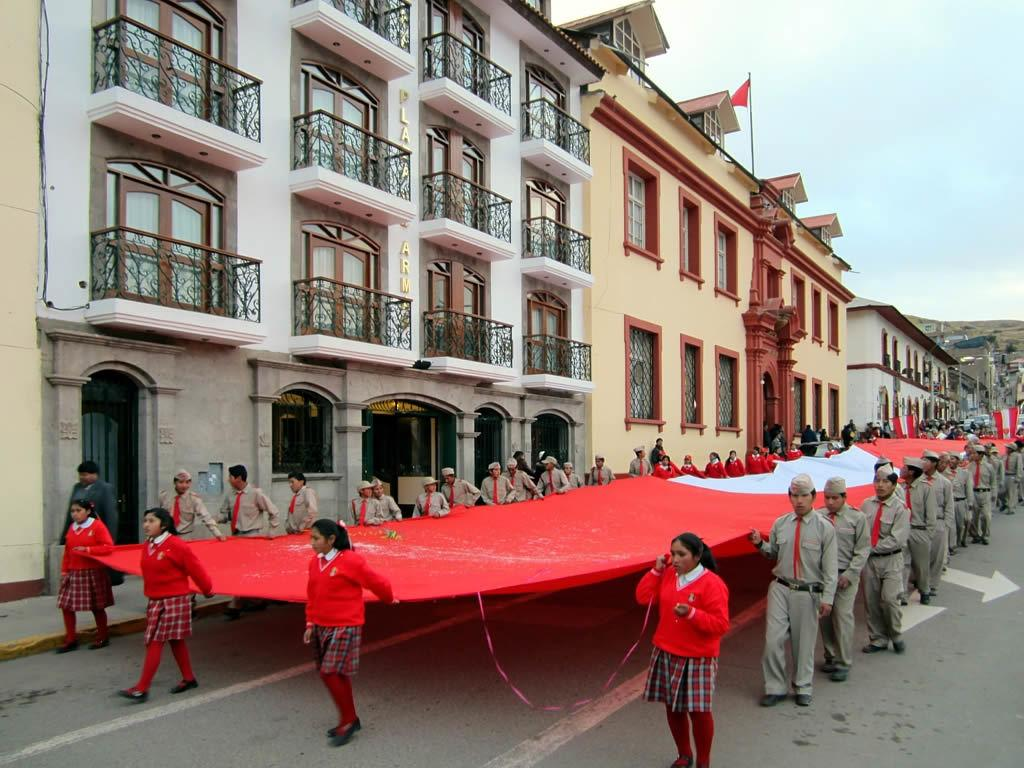What are the people in the image doing? The people in the image are walking on the road. What are the people holding while walking? The people are holding a cloth. What can be seen in the background of the image? There are buildings visible near the side of the road. How many giants can be seen walking on the road in the image? There are no giants present in the image; only people are visible walking on the road. What type of liquid is being crushed by the people walking on the road? There is no liquid being crushed in the image; the people are holding a cloth while walking on the road. 